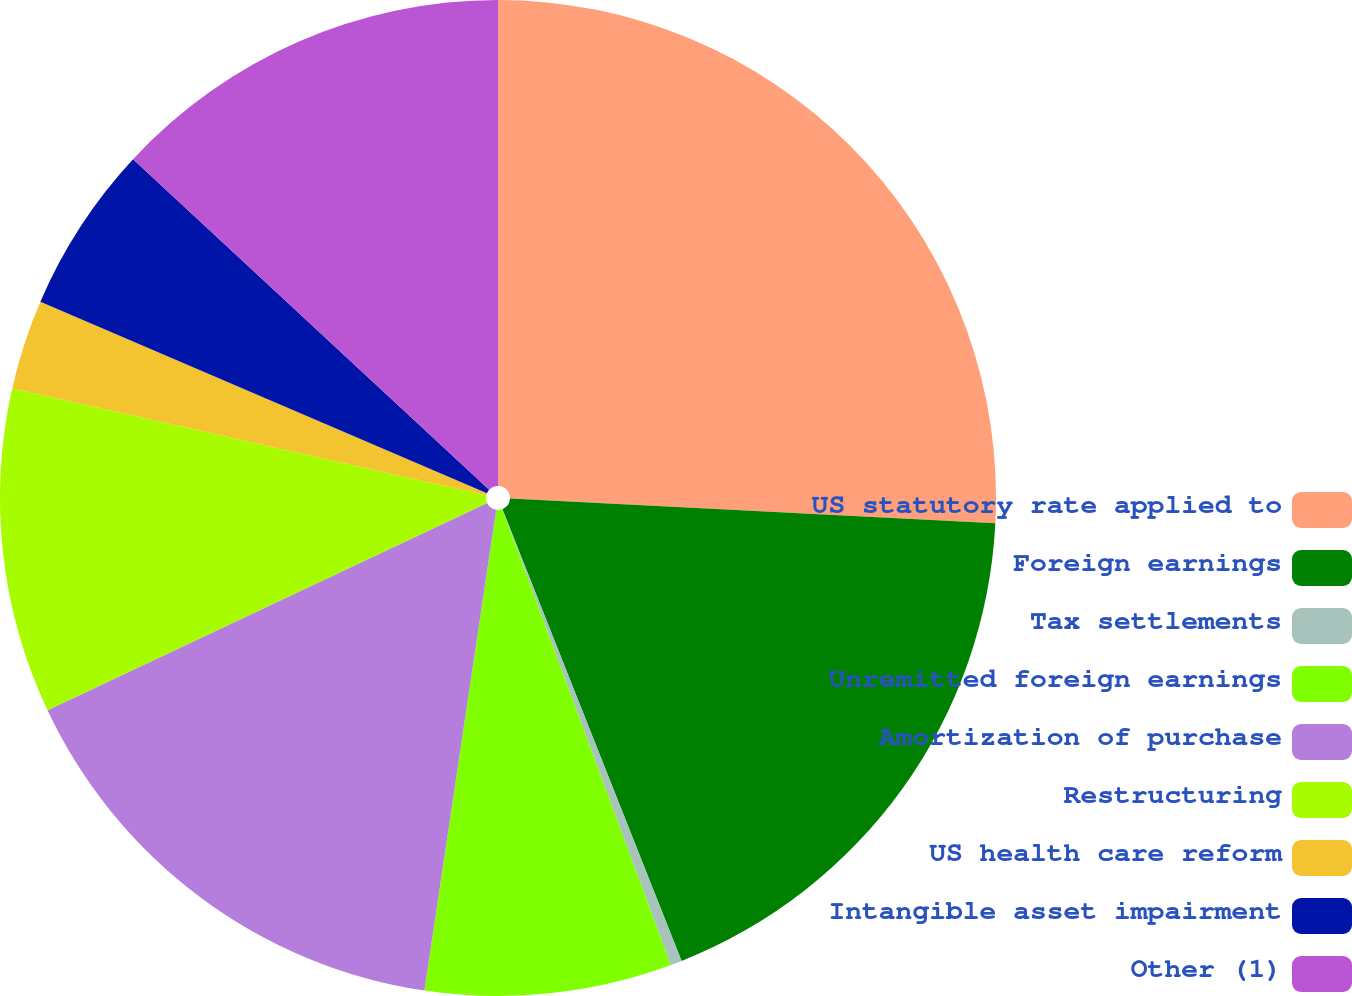Convert chart to OTSL. <chart><loc_0><loc_0><loc_500><loc_500><pie_chart><fcel>US statutory rate applied to<fcel>Foreign earnings<fcel>Tax settlements<fcel>Unremitted foreign earnings<fcel>Amortization of purchase<fcel>Restructuring<fcel>US health care reform<fcel>Intangible asset impairment<fcel>Other (1)<nl><fcel>25.81%<fcel>18.18%<fcel>0.37%<fcel>8.0%<fcel>15.63%<fcel>10.55%<fcel>2.91%<fcel>5.46%<fcel>13.09%<nl></chart> 